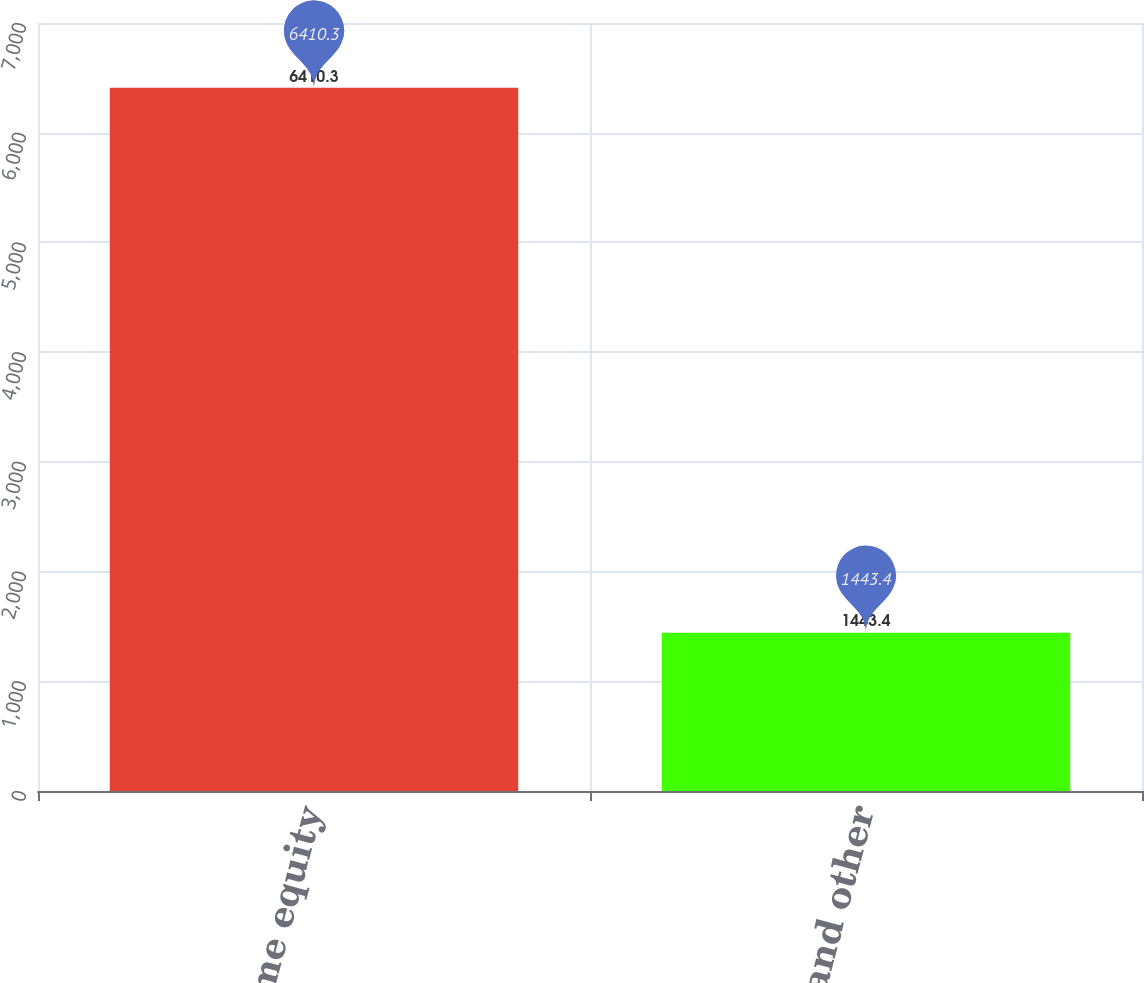Convert chart. <chart><loc_0><loc_0><loc_500><loc_500><bar_chart><fcel>Home equity<fcel>Consumer and other<nl><fcel>6410.3<fcel>1443.4<nl></chart> 